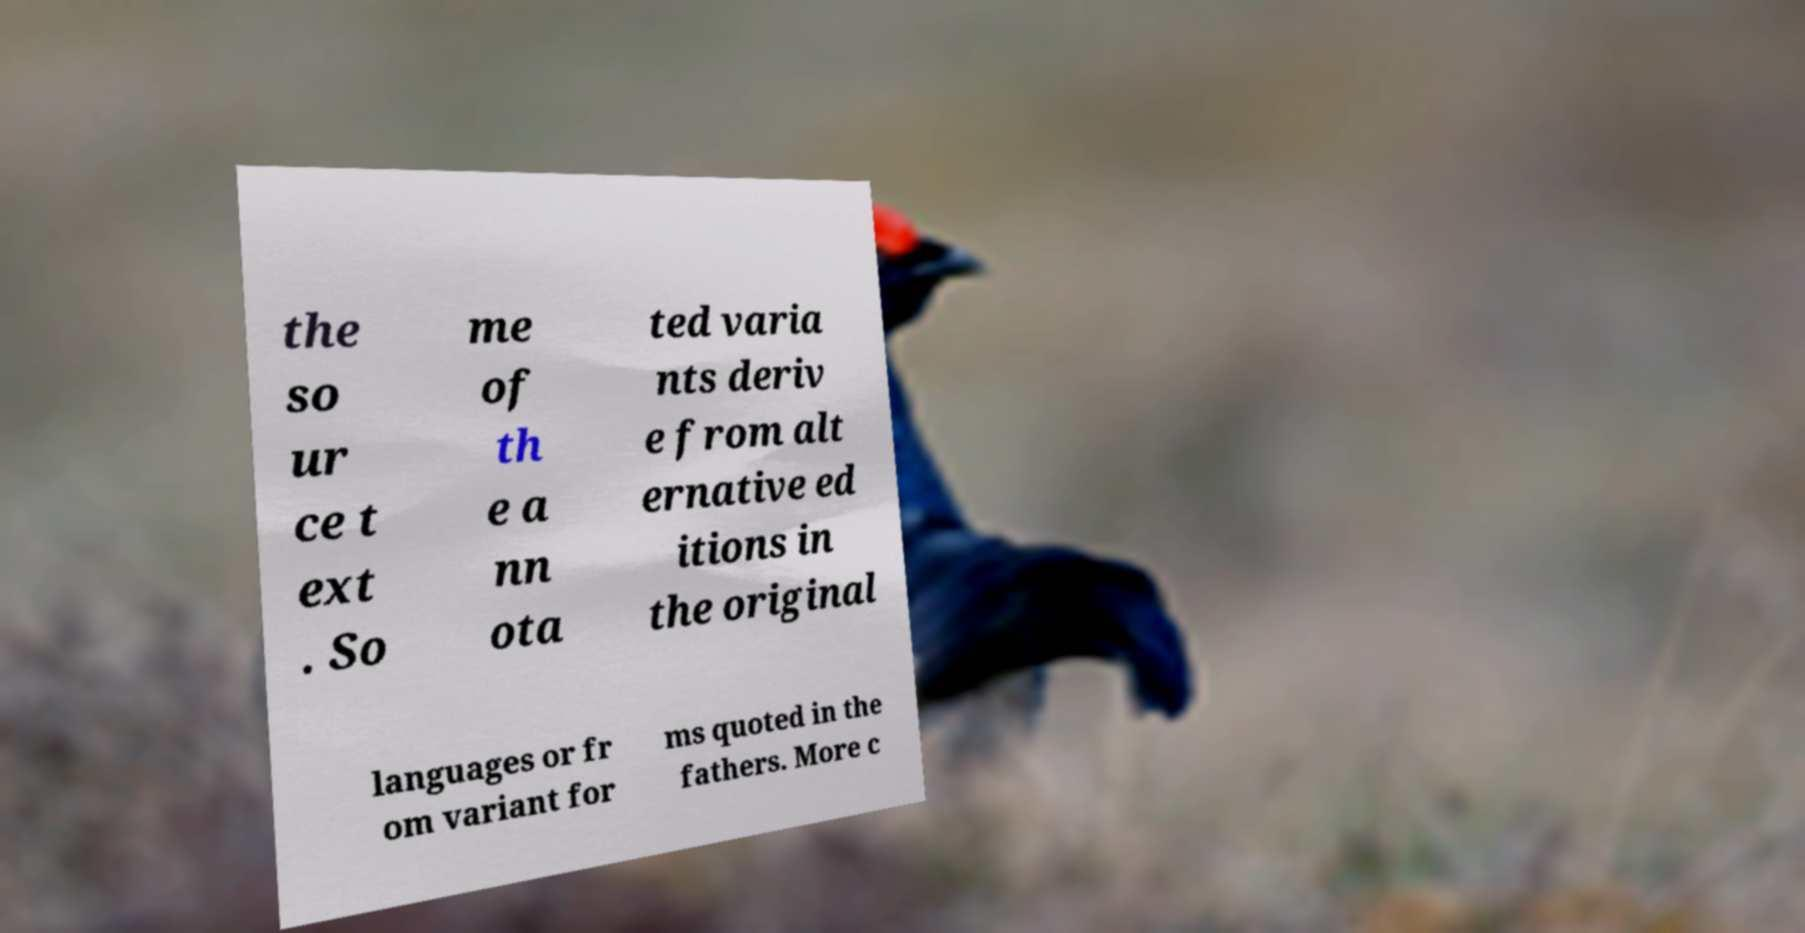Could you assist in decoding the text presented in this image and type it out clearly? the so ur ce t ext . So me of th e a nn ota ted varia nts deriv e from alt ernative ed itions in the original languages or fr om variant for ms quoted in the fathers. More c 